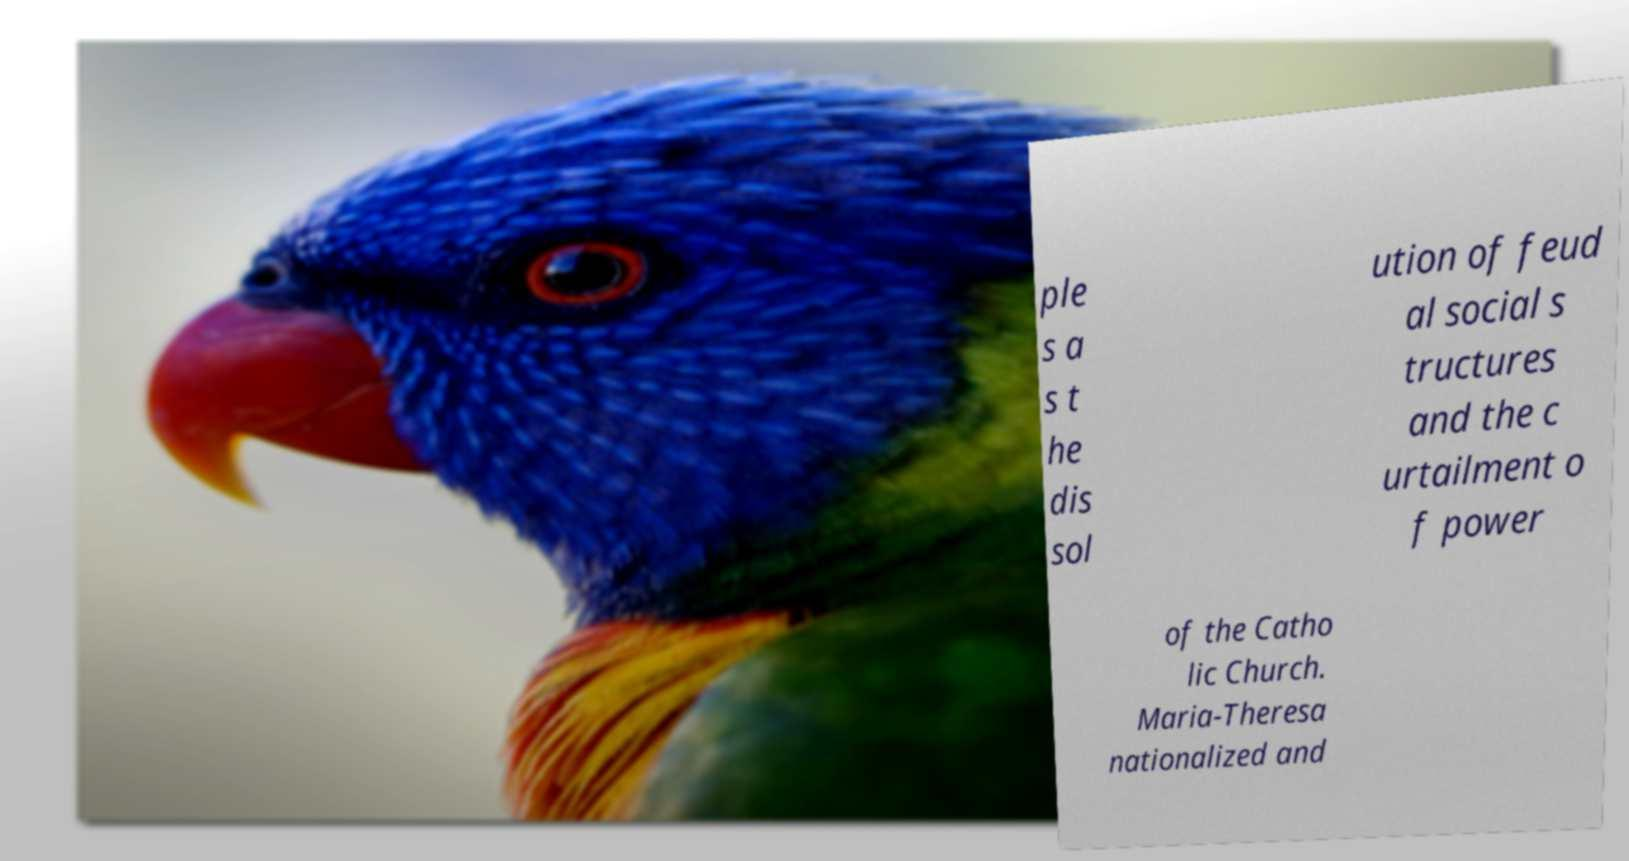For documentation purposes, I need the text within this image transcribed. Could you provide that? ple s a s t he dis sol ution of feud al social s tructures and the c urtailment o f power of the Catho lic Church. Maria-Theresa nationalized and 